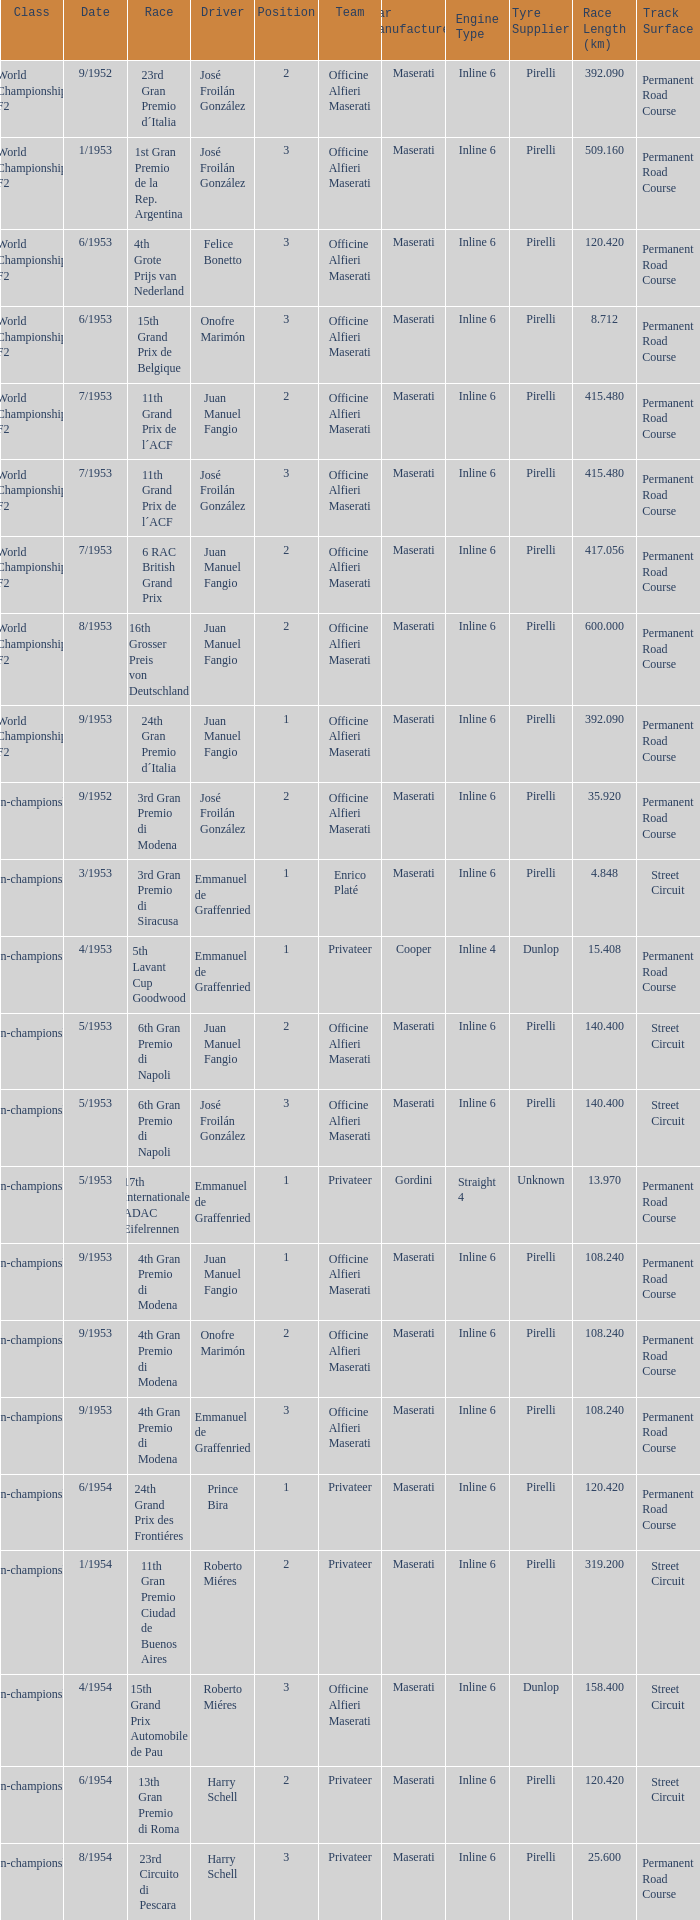What team has a drive name emmanuel de graffenried and a position larger than 1 as well as the date of 9/1953? Officine Alfieri Maserati. Could you parse the entire table? {'header': ['Class', 'Date', 'Race', 'Driver', 'Position', 'Team', 'Car Manufacturer', 'Engine Type', 'Tyre Supplier', 'Race Length (km)', 'Track Surface'], 'rows': [['World Championship F2', '9/1952', '23rd Gran Premio d´Italia', 'José Froilán González', '2', 'Officine Alfieri Maserati', 'Maserati', 'Inline 6', 'Pirelli', '392.090', 'Permanent Road Course'], ['World Championship F2', '1/1953', '1st Gran Premio de la Rep. Argentina', 'José Froilán González', '3', 'Officine Alfieri Maserati', 'Maserati', 'Inline 6', 'Pirelli', '509.160', 'Permanent Road Course'], ['World Championship F2', '6/1953', '4th Grote Prijs van Nederland', 'Felice Bonetto', '3', 'Officine Alfieri Maserati', 'Maserati', 'Inline 6', 'Pirelli', '120.420', 'Permanent Road Course'], ['World Championship F2', '6/1953', '15th Grand Prix de Belgique', 'Onofre Marimón', '3', 'Officine Alfieri Maserati', 'Maserati', 'Inline 6', 'Pirelli', '8.712', 'Permanent Road Course'], ['World Championship F2', '7/1953', '11th Grand Prix de l´ACF', 'Juan Manuel Fangio', '2', 'Officine Alfieri Maserati', 'Maserati', 'Inline 6', 'Pirelli', '415.480', 'Permanent Road Course'], ['World Championship F2', '7/1953', '11th Grand Prix de l´ACF', 'José Froilán González', '3', 'Officine Alfieri Maserati', 'Maserati', 'Inline 6', 'Pirelli', '415.480', 'Permanent Road Course'], ['World Championship F2', '7/1953', '6 RAC British Grand Prix', 'Juan Manuel Fangio', '2', 'Officine Alfieri Maserati', 'Maserati', 'Inline 6', 'Pirelli', '417.056', 'Permanent Road Course'], ['World Championship F2', '8/1953', '16th Grosser Preis von Deutschland', 'Juan Manuel Fangio', '2', 'Officine Alfieri Maserati', 'Maserati', 'Inline 6', 'Pirelli', '600.000', 'Permanent Road Course'], ['World Championship F2', '9/1953', '24th Gran Premio d´Italia', 'Juan Manuel Fangio', '1', 'Officine Alfieri Maserati', 'Maserati', 'Inline 6', 'Pirelli', '392.090', 'Permanent Road Course'], ['Non-championship F2', '9/1952', '3rd Gran Premio di Modena', 'José Froilán González', '2', 'Officine Alfieri Maserati', 'Maserati', 'Inline 6', 'Pirelli', '35.920', 'Permanent Road Course'], ['Non-championship F2', '3/1953', '3rd Gran Premio di Siracusa', 'Emmanuel de Graffenried', '1', 'Enrico Platé', 'Maserati', 'Inline 6', 'Pirelli', '4.848', 'Street Circuit'], ['Non-championship F2', '4/1953', '5th Lavant Cup Goodwood', 'Emmanuel de Graffenried', '1', 'Privateer', 'Cooper', 'Inline 4', 'Dunlop', '15.408', 'Permanent Road Course'], ['Non-championship F2', '5/1953', '6th Gran Premio di Napoli', 'Juan Manuel Fangio', '2', 'Officine Alfieri Maserati', 'Maserati', 'Inline 6', 'Pirelli', '140.400', 'Street Circuit'], ['Non-championship F2', '5/1953', '6th Gran Premio di Napoli', 'José Froilán González', '3', 'Officine Alfieri Maserati', 'Maserati', 'Inline 6', 'Pirelli', '140.400', 'Street Circuit'], ['Non-championship F2', '5/1953', '17th Internationales ADAC Eifelrennen', 'Emmanuel de Graffenried', '1', 'Privateer', 'Gordini', 'Straight 4', 'Unknown', '13.970', 'Permanent Road Course'], ['Non-championship F2', '9/1953', '4th Gran Premio di Modena', 'Juan Manuel Fangio', '1', 'Officine Alfieri Maserati', 'Maserati', 'Inline 6', 'Pirelli', '108.240', 'Permanent Road Course'], ['Non-championship F2', '9/1953', '4th Gran Premio di Modena', 'Onofre Marimón', '2', 'Officine Alfieri Maserati', 'Maserati', 'Inline 6', 'Pirelli', '108.240', 'Permanent Road Course'], ['Non-championship F2', '9/1953', '4th Gran Premio di Modena', 'Emmanuel de Graffenried', '3', 'Officine Alfieri Maserati', 'Maserati', 'Inline 6', 'Pirelli', '108.240', 'Permanent Road Course'], ['(Non-championship) F2', '6/1954', '24th Grand Prix des Frontiéres', 'Prince Bira', '1', 'Privateer', 'Maserati', 'Inline 6', 'Pirelli', '120.420', 'Permanent Road Course'], ['Non-championship F1', '1/1954', '11th Gran Premio Ciudad de Buenos Aires', 'Roberto Miéres', '2', 'Privateer', 'Maserati', 'Inline 6', 'Pirelli', '319.200', 'Street Circuit'], ['Non-championship F1', '4/1954', '15th Grand Prix Automobile de Pau', 'Roberto Miéres', '3', 'Officine Alfieri Maserati', 'Maserati', 'Inline 6', 'Dunlop', '158.400', 'Street Circuit'], ['Non-championship F1', '6/1954', '13th Gran Premio di Roma', 'Harry Schell', '2', 'Privateer', 'Maserati', 'Inline 6', 'Pirelli', '120.420', 'Street Circuit'], ['Non-championship F1', '8/1954', '23rd Circuito di Pescara', 'Harry Schell', '3', 'Privateer', 'Maserati', 'Inline 6', 'Pirelli', '25.600', 'Permanent Road Course']]} 